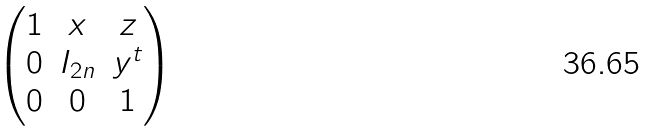Convert formula to latex. <formula><loc_0><loc_0><loc_500><loc_500>\begin{pmatrix} 1 & x & z \\ 0 & I _ { 2 n } & y ^ { t } \\ 0 & 0 & 1 \\ \end{pmatrix}</formula> 